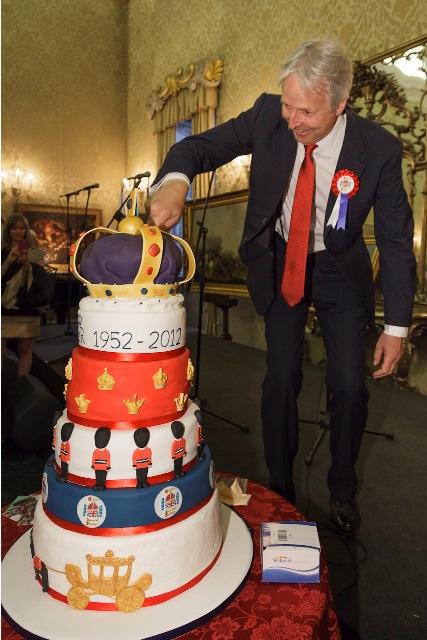Is this a cake?
Be succinct. Yes. What colors are the crown on the cake?
Be succinct. Purple and gold. How many tiers?
Concise answer only. 5. 